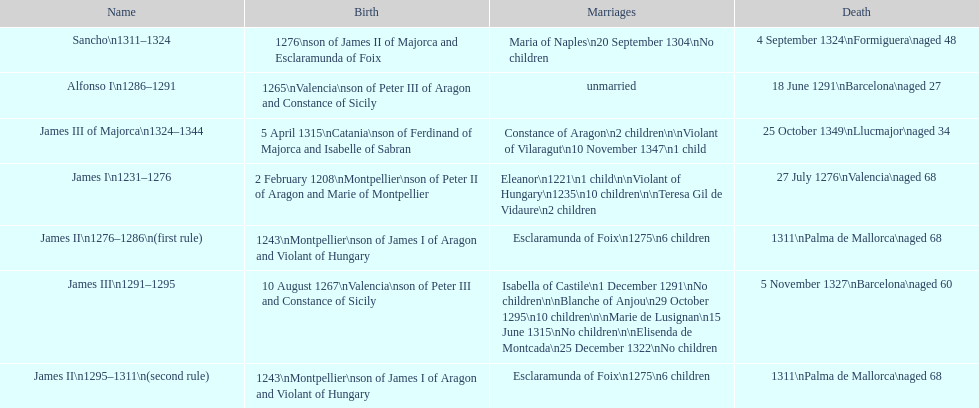How many total marriages did james i have? 3. 